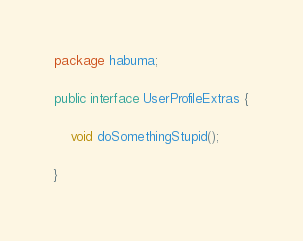Convert code to text. <code><loc_0><loc_0><loc_500><loc_500><_Java_>package habuma;

public interface UserProfileExtras {

	void doSomethingStupid();
	
}
</code> 